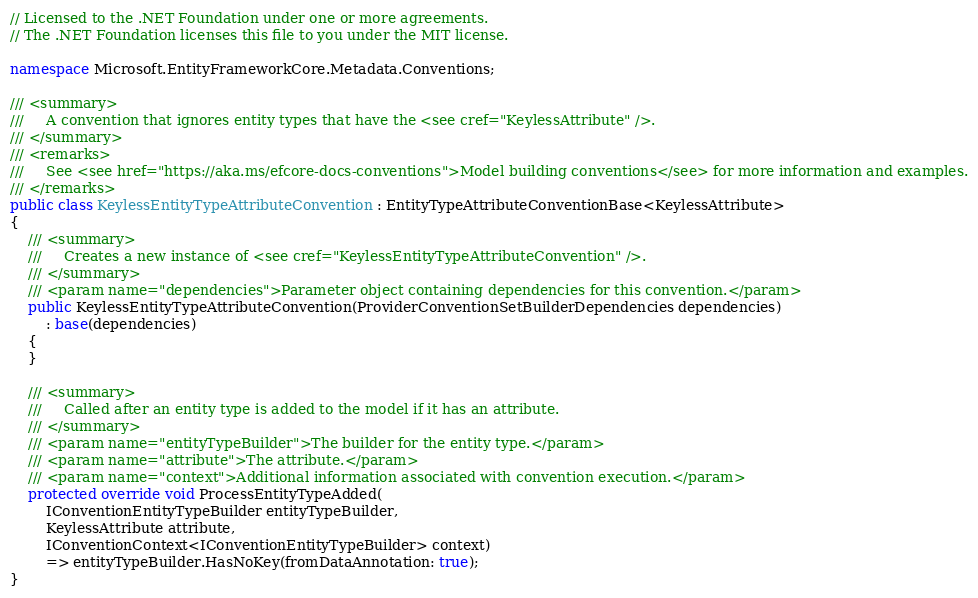Convert code to text. <code><loc_0><loc_0><loc_500><loc_500><_C#_>// Licensed to the .NET Foundation under one or more agreements.
// The .NET Foundation licenses this file to you under the MIT license.

namespace Microsoft.EntityFrameworkCore.Metadata.Conventions;

/// <summary>
///     A convention that ignores entity types that have the <see cref="KeylessAttribute" />.
/// </summary>
/// <remarks>
///     See <see href="https://aka.ms/efcore-docs-conventions">Model building conventions</see> for more information and examples.
/// </remarks>
public class KeylessEntityTypeAttributeConvention : EntityTypeAttributeConventionBase<KeylessAttribute>
{
    /// <summary>
    ///     Creates a new instance of <see cref="KeylessEntityTypeAttributeConvention" />.
    /// </summary>
    /// <param name="dependencies">Parameter object containing dependencies for this convention.</param>
    public KeylessEntityTypeAttributeConvention(ProviderConventionSetBuilderDependencies dependencies)
        : base(dependencies)
    {
    }

    /// <summary>
    ///     Called after an entity type is added to the model if it has an attribute.
    /// </summary>
    /// <param name="entityTypeBuilder">The builder for the entity type.</param>
    /// <param name="attribute">The attribute.</param>
    /// <param name="context">Additional information associated with convention execution.</param>
    protected override void ProcessEntityTypeAdded(
        IConventionEntityTypeBuilder entityTypeBuilder,
        KeylessAttribute attribute,
        IConventionContext<IConventionEntityTypeBuilder> context)
        => entityTypeBuilder.HasNoKey(fromDataAnnotation: true);
}
</code> 